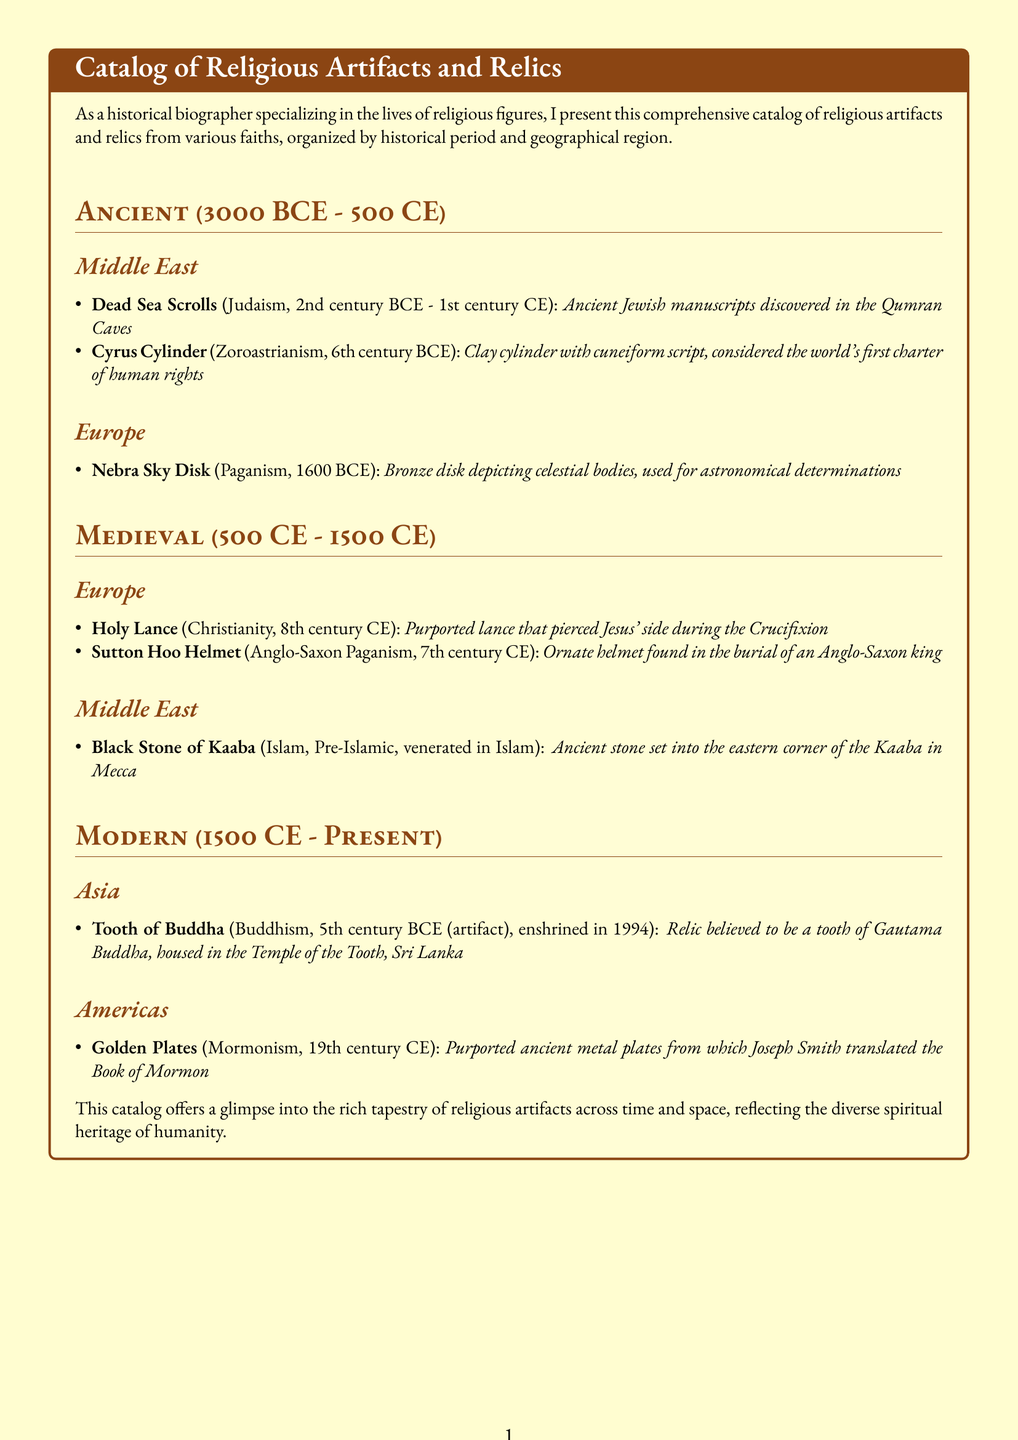What is the time period of the Dead Sea Scrolls? The time period of the Dead Sea Scrolls is specified as 2nd century BCE - 1st century CE.
Answer: 2nd century BCE - 1st century CE Which religious artifact is associated with Zoroastrianism? The artifact associated with Zoroastrianism in the document is the Cyrus Cylinder.
Answer: Cyrus Cylinder What century is the Holy Lance from? The Holy Lance is from the 8th century CE, as stated in the document.
Answer: 8th century CE How many artifacts are listed under Medieval artifacts? The document lists three artifacts under the Medieval section.
Answer: 3 In which region is the Black Stone of Kaaba located? The Black Stone of Kaaba is located in the Middle East, as indicated in the document.
Answer: Middle East Which faith is associated with the Golden Plates? The faith associated with the Golden Plates, according to the document, is Mormonism.
Answer: Mormonism What year were the Tooth of Buddha relics enshrined? The Tooth of Buddha relics were enshrined in 1994, as per the document.
Answer: 1994 What material is the Nebra Sky Disk made of? The Nebra Sky Disk is made of bronze, as noted in the document.
Answer: Bronze Which period does the Sutton Hoo Helmet belong to? The Sutton Hoo Helmet belongs to the Medieval period, as mentioned in the document.
Answer: Medieval 